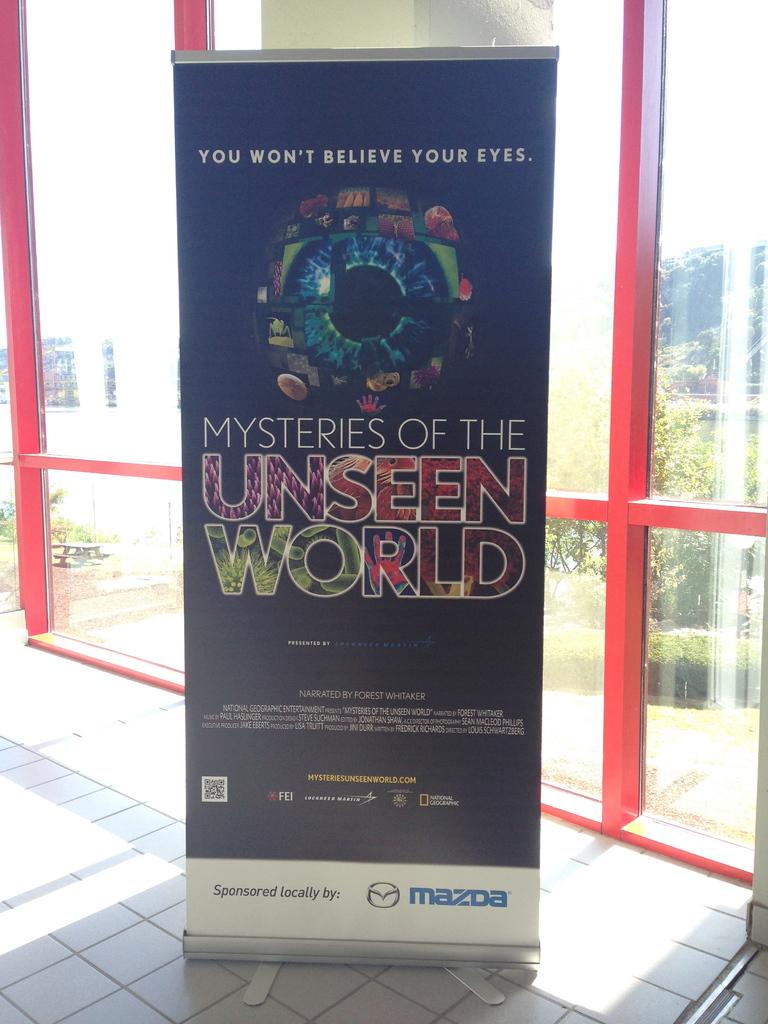What are these the mysteries of?
Provide a succinct answer. The unseen world. What car brand is on the bottom right?
Provide a succinct answer. Mazda. 